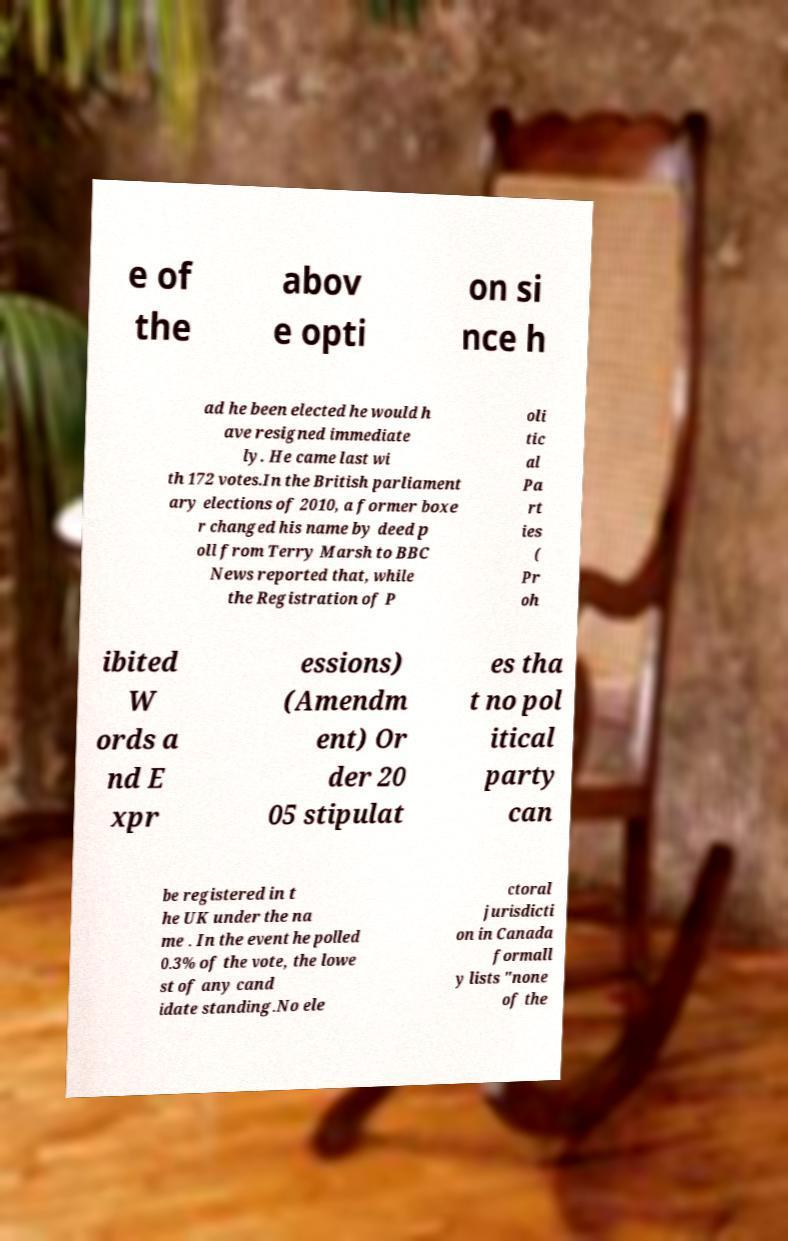There's text embedded in this image that I need extracted. Can you transcribe it verbatim? e of the abov e opti on si nce h ad he been elected he would h ave resigned immediate ly. He came last wi th 172 votes.In the British parliament ary elections of 2010, a former boxe r changed his name by deed p oll from Terry Marsh to BBC News reported that, while the Registration of P oli tic al Pa rt ies ( Pr oh ibited W ords a nd E xpr essions) (Amendm ent) Or der 20 05 stipulat es tha t no pol itical party can be registered in t he UK under the na me . In the event he polled 0.3% of the vote, the lowe st of any cand idate standing.No ele ctoral jurisdicti on in Canada formall y lists "none of the 